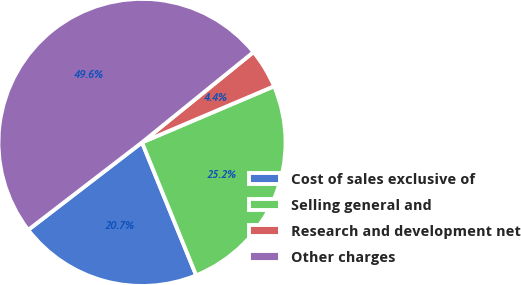Convert chart to OTSL. <chart><loc_0><loc_0><loc_500><loc_500><pie_chart><fcel>Cost of sales exclusive of<fcel>Selling general and<fcel>Research and development net<fcel>Other charges<nl><fcel>20.73%<fcel>25.24%<fcel>4.44%<fcel>49.59%<nl></chart> 